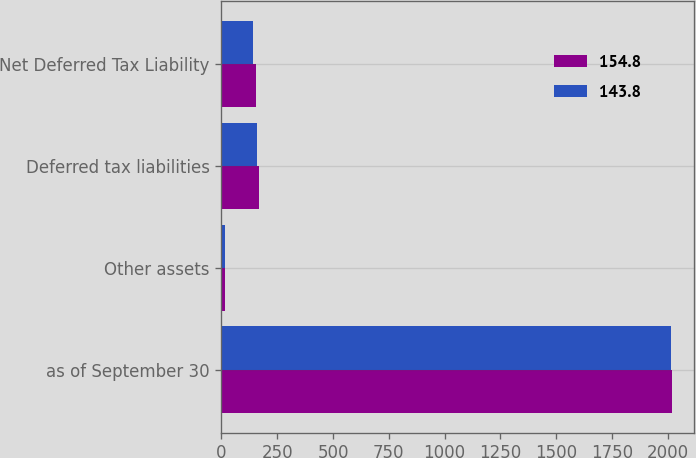Convert chart to OTSL. <chart><loc_0><loc_0><loc_500><loc_500><stacked_bar_chart><ecel><fcel>as of September 30<fcel>Other assets<fcel>Deferred tax liabilities<fcel>Net Deferred Tax Liability<nl><fcel>154.8<fcel>2017<fcel>15.8<fcel>170.6<fcel>154.8<nl><fcel>143.8<fcel>2016<fcel>17.7<fcel>161.5<fcel>143.8<nl></chart> 